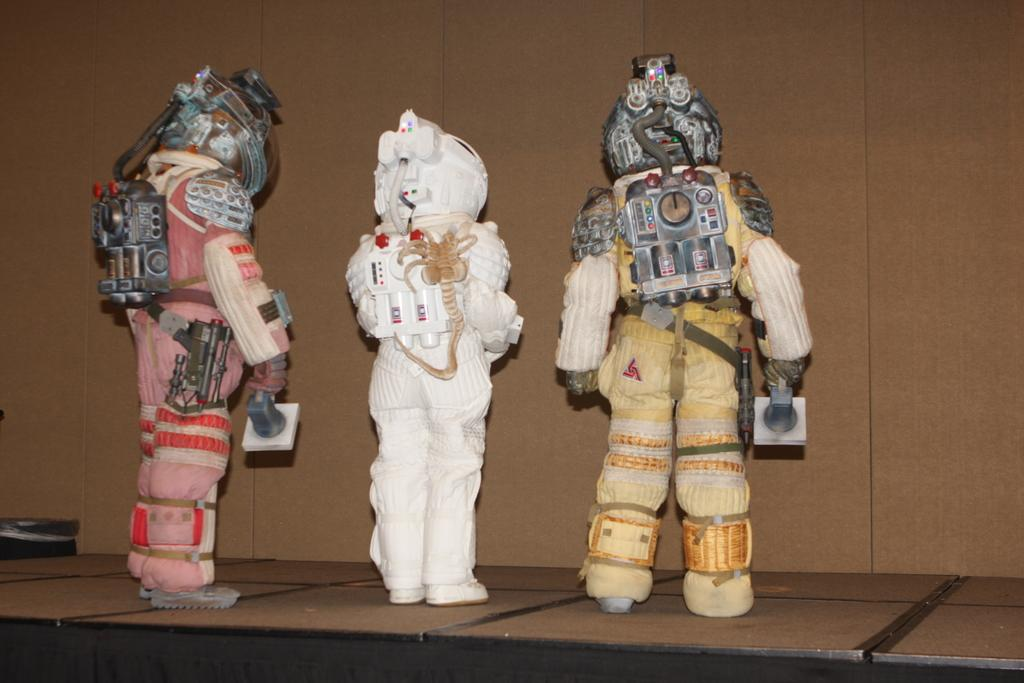How many toys can be seen in the image? There are three toys in the image. Where are the toys located? The toys are on a surface that resembles a table. What is present on the left side of the image? There is an object on the left side of the image. What type of wall can be seen in the background of the image? The background of the image features a wooden wall. Is there a man taking a recess in the image? There is no man or recess present in the image. The image only features three toys on a table with a wooden wall in the background. 